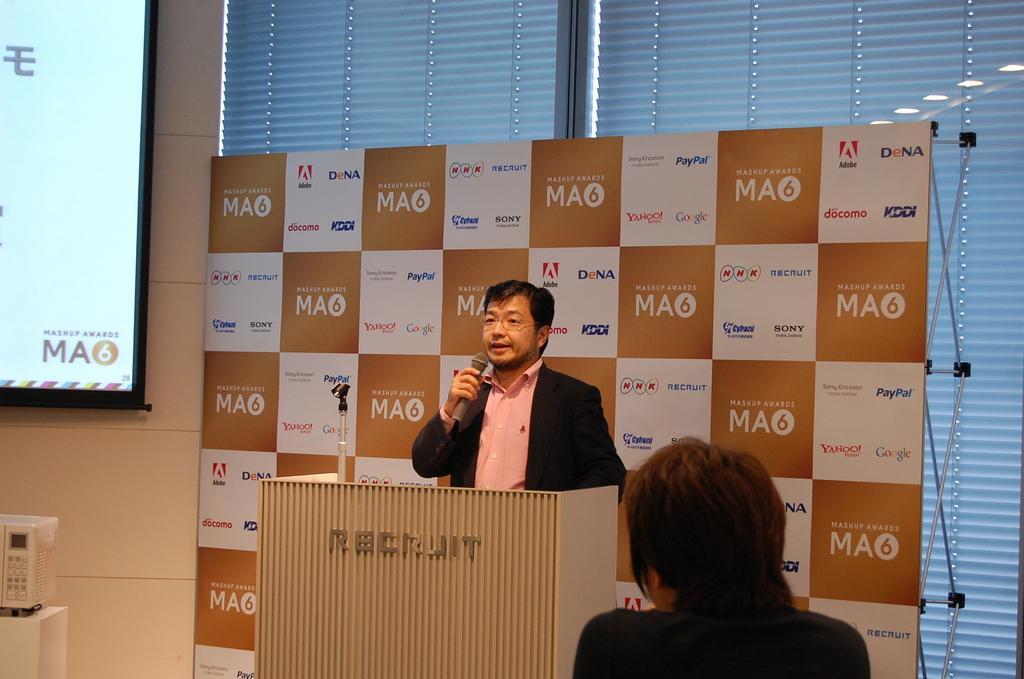Can you describe this image briefly? In this picture we can see few people, in the middle of the given image we can see a man, he is talking with the help of microphone and he is standing in front of the podium, in the background we can see a hoarding, window blinds and a projector screen. 